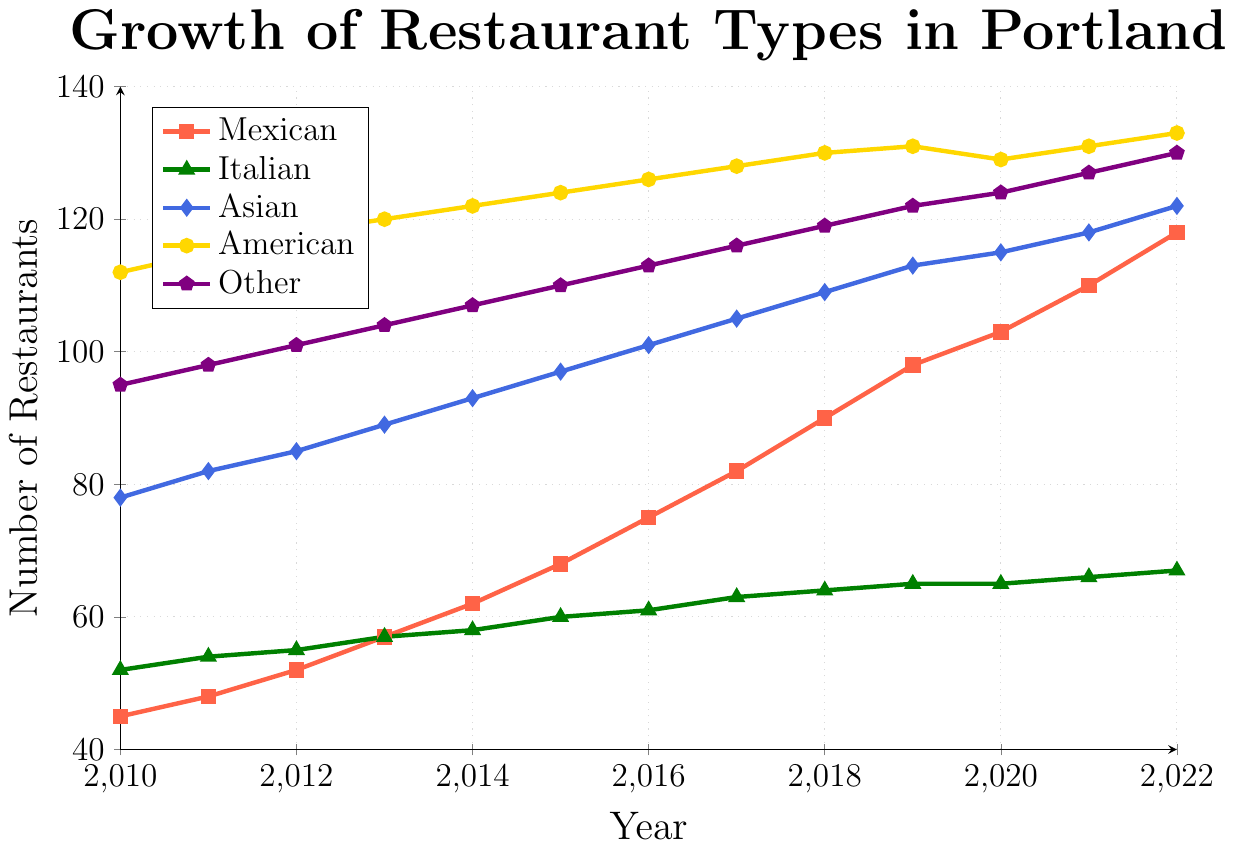Which cuisine type had the highest number of restaurants in 2010? Look at the y-values for 2010 and identify the highest one. The highest value in 2010 is 112 for American cuisine.
Answer: American How many more Mexican restaurants were there in 2020 compared to 2010? Subtract the number of Mexican restaurants in 2010 from the number in 2020: 103 - 45 = 58.
Answer: 58 By how much did the number of Asian restaurants increase from 2014 to 2022? Subtract the number of Asian restaurants in 2014 from the number in 2022: 122 - 93 = 29.
Answer: 29 Which cuisine type showed the least growth from 2010 to 2022? Calculate the growth for each cuisine by subtracting the 2010 values from the 2022 values and find the smallest value: Italian (67-52=15), Asian (122-78=44), American (133-112=21), Other (130-95=35), Mexican (118-45=73). Italian has the smallest growth of 15.
Answer: Italian In what year did Mexican restaurants surpass the number of Asian restaurants? Compare Mexican and Asian restaurant data points year by year. In 2020, Mexican (103) surpassed Asian (115). In 2021, Mexican (110) surpassed Asian (118). Therefore, 2022 is when it happened definitively: Mexican 118, Asian 122. So 2022 is the answer.
Answer: 2022 How many years did it take for the number of Mexican restaurants to double from the initial count in 2010? Find the year where the number of Mexican restaurants is at least double the 2010 value (45 x 2 = 90). The number doubled in 2018 when it reached 90.
Answer: 8 years What is the average yearly growth rate of American restaurants from 2010 to 2022? Calculate the total growth and then the average yearly increase. Total growth from 2010 to 2022 is 133 - 112 = 21. Average yearly growth is 21 / 12 = 1.75.
Answer: 1.75 restaurants per year Between which years did Mexican restaurants see the highest yearly growth? Compare the yearly increase in the number of Mexican restaurants by subtracting consecutive years. Highest growth is between 2017 (82) and 2018 (90): 90 - 82 = 8.
Answer: 2017 to 2018 How does the growth trend of Mexican restaurants compare to Italian restaurants over the years? Mexican restaurants show a consistent increase over the years, while the growth of Italian restaurants is more gradual and flattens out after 2020.
Answer: Mexican restaurants have a steeper growth trend Which year did American restaurants see a decline in numbers? Look for a decrease in the count of American restaurants. Between 2019 (131) and 2020 (129), there was a decline.
Answer: 2020 